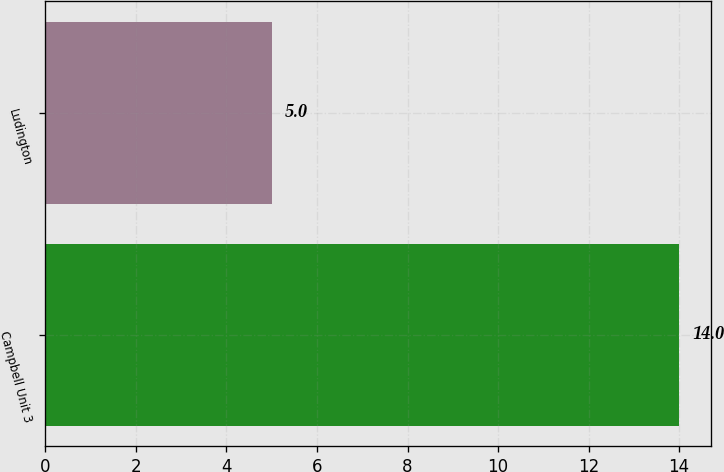Convert chart. <chart><loc_0><loc_0><loc_500><loc_500><bar_chart><fcel>Campbell Unit 3<fcel>Ludington<nl><fcel>14<fcel>5<nl></chart> 